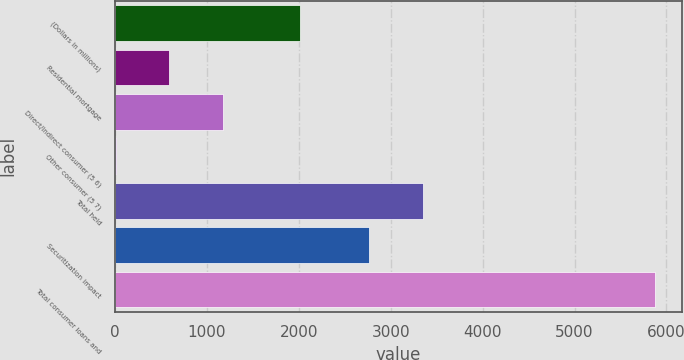Convert chart to OTSL. <chart><loc_0><loc_0><loc_500><loc_500><bar_chart><fcel>(Dollars in millions)<fcel>Residential mortgage<fcel>Direct/Indirect consumer (5 6)<fcel>Other consumer (5 7)<fcel>Total held<fcel>Securitization impact<fcel>Total consumer loans and<nl><fcel>2007<fcel>591.3<fcel>1178.6<fcel>4<fcel>3351.3<fcel>2764<fcel>5877<nl></chart> 